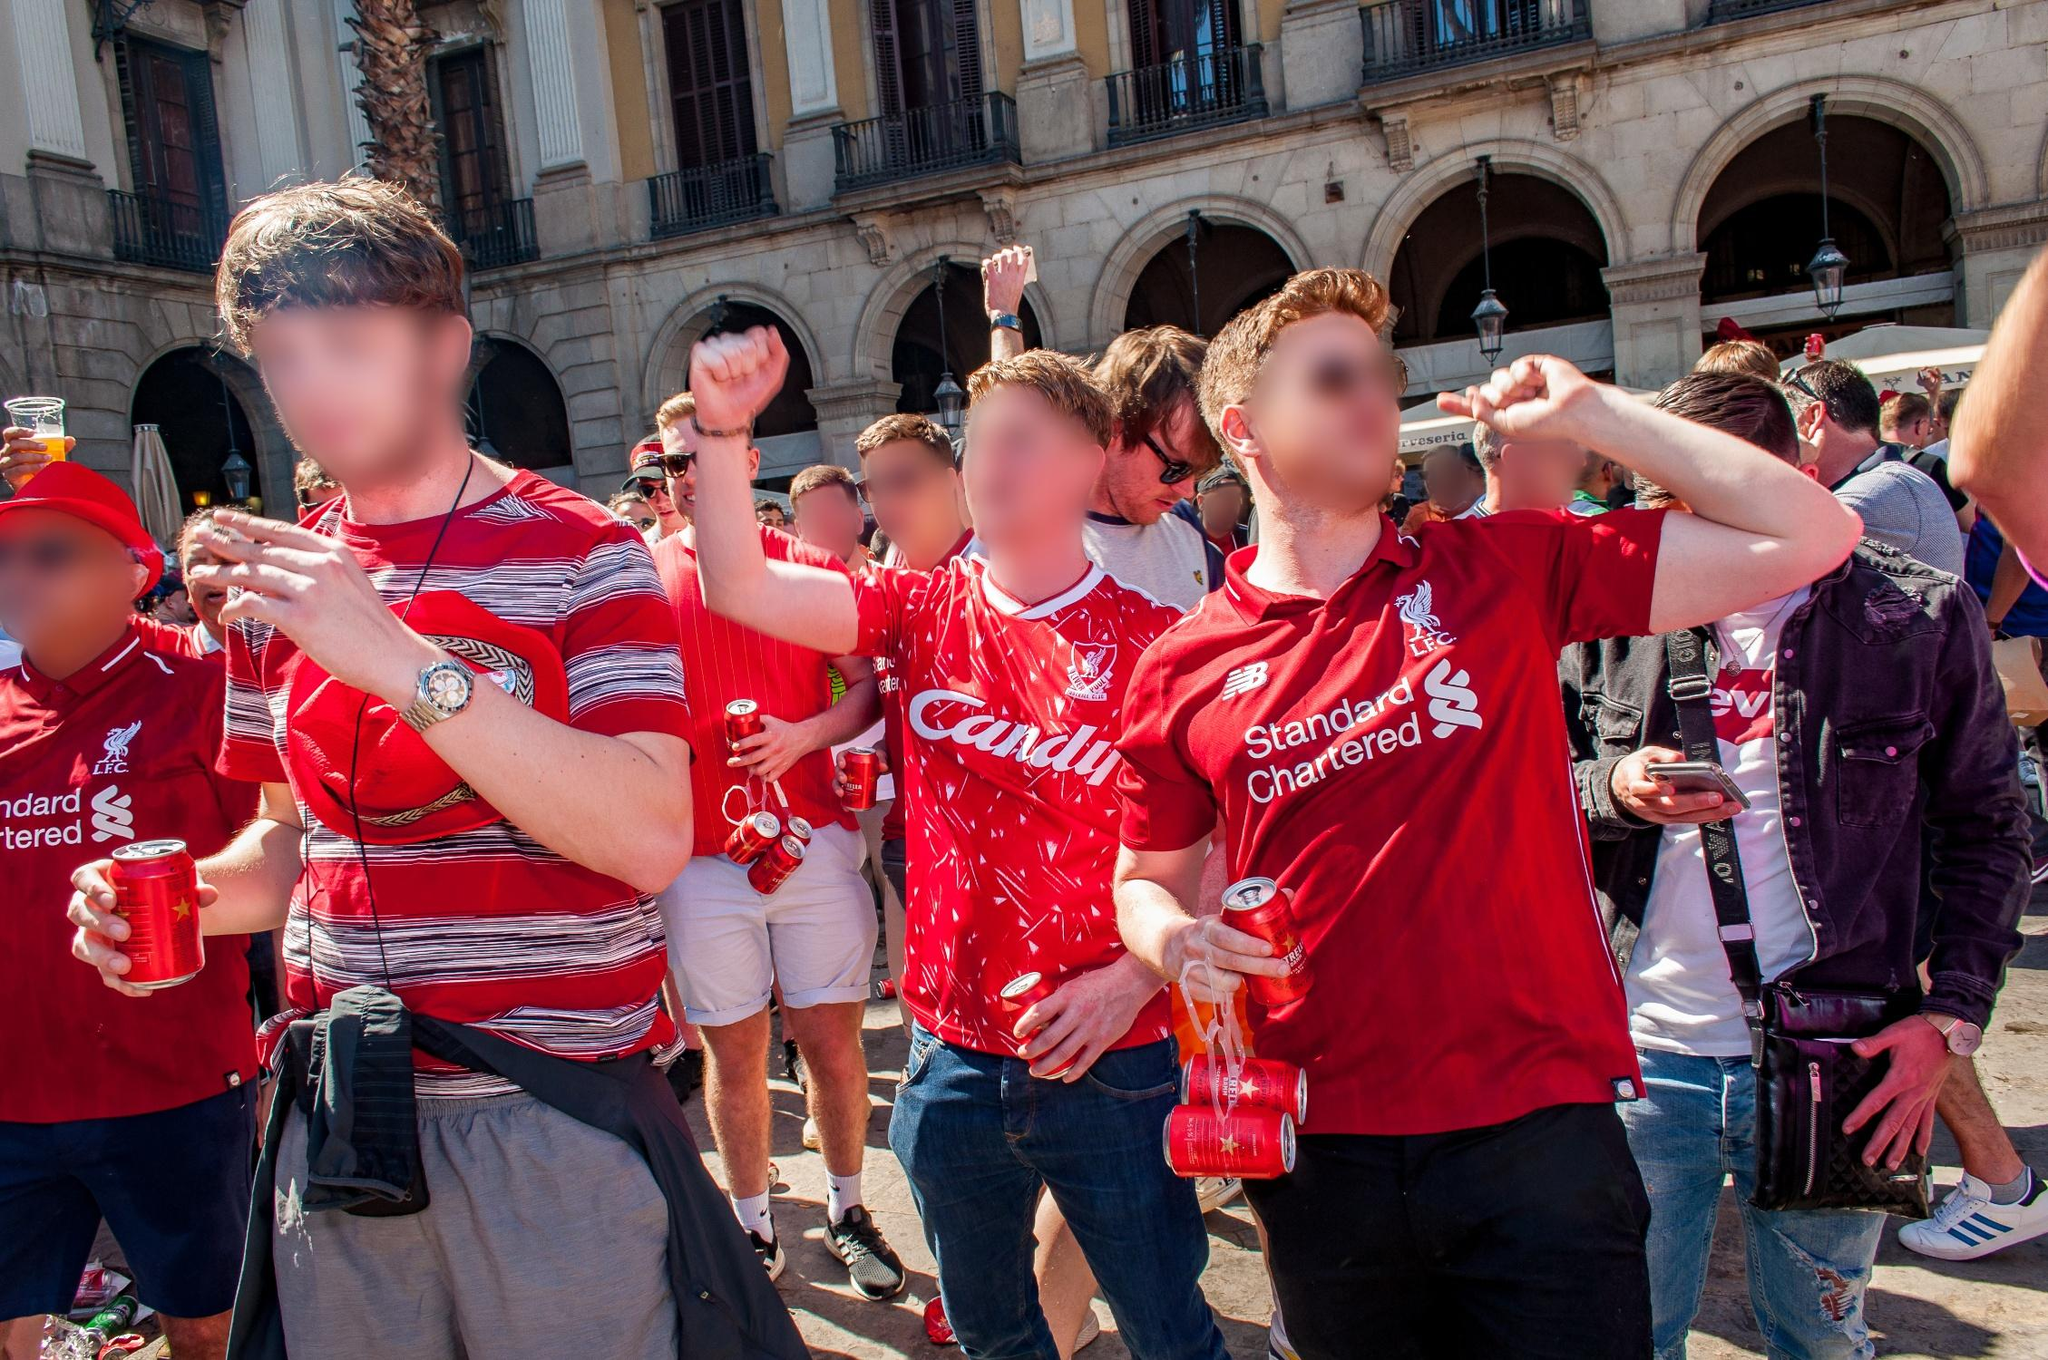What might be the reason for their celebration? Based on the image, it appears that the people may be celebrating a sports victory or a momentous event related to their club. The red shirts with logos such as 'Candil' and 'Standard Chartered' indicate that they are likely supporters or members of a sports team, possibly a football club. The general mood of triumph and joy further suggests a recent win or significant achievement for which they are gathered to celebrate. 